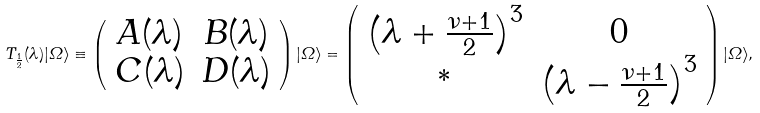<formula> <loc_0><loc_0><loc_500><loc_500>T _ { \frac { 1 } { 2 } } ( \lambda ) | { \mathit \Omega } \rangle \equiv \left ( \begin{array} { c c } A ( \lambda ) & B ( \lambda ) \\ C ( \lambda ) & D ( \lambda ) \end{array} \right ) | { \mathit \Omega } \rangle = \left ( \begin{array} { c c } \left ( \lambda + \frac { \nu + 1 } { 2 } \right ) ^ { 3 } & 0 \\ ^ { * } & \left ( \lambda - \frac { \nu + 1 } { 2 } \right ) ^ { 3 } \end{array} \right ) | { \mathit \Omega } \rangle ,</formula> 